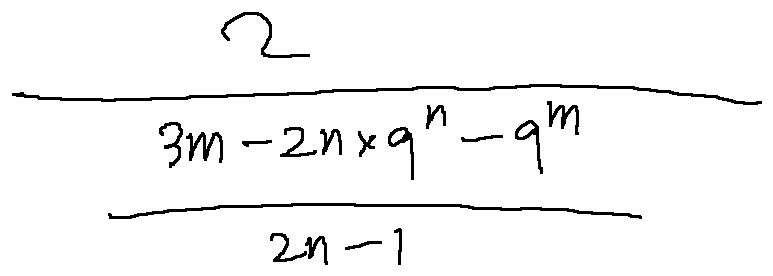<formula> <loc_0><loc_0><loc_500><loc_500>\frac { 2 } { \frac { 3 m - 2 n \times 9 ^ { n } - 9 ^ { m } } { 2 n - 1 } }</formula> 